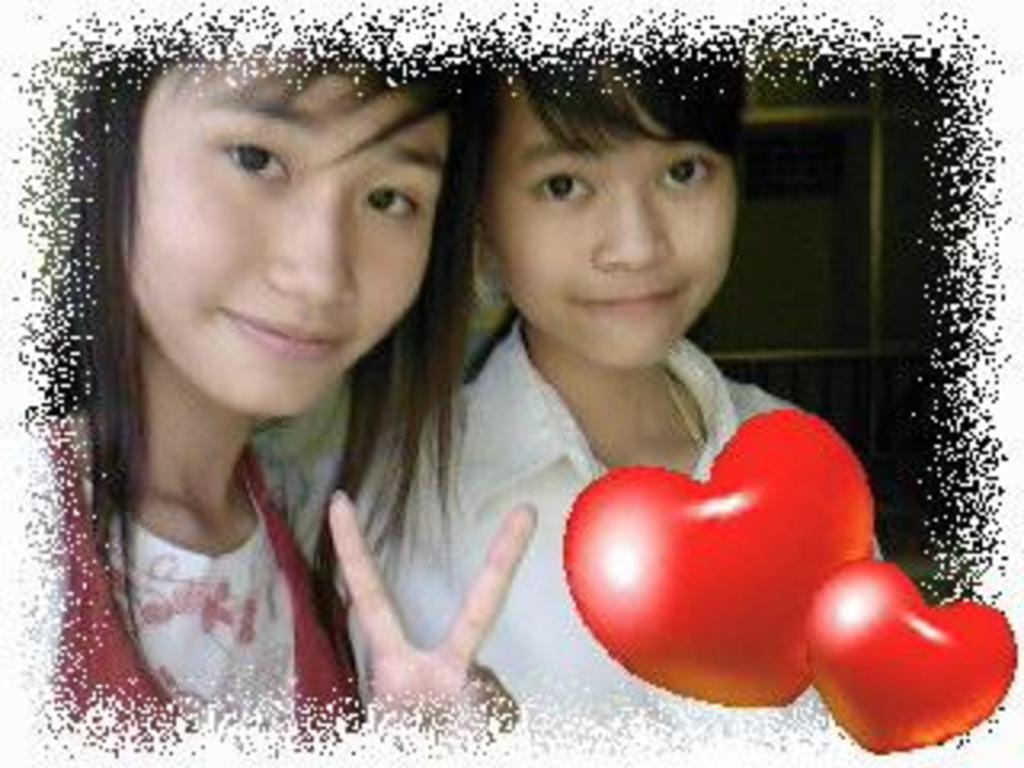Can you describe this image briefly? In this image we can see two women. And in the bottom right we can see the watermark. 